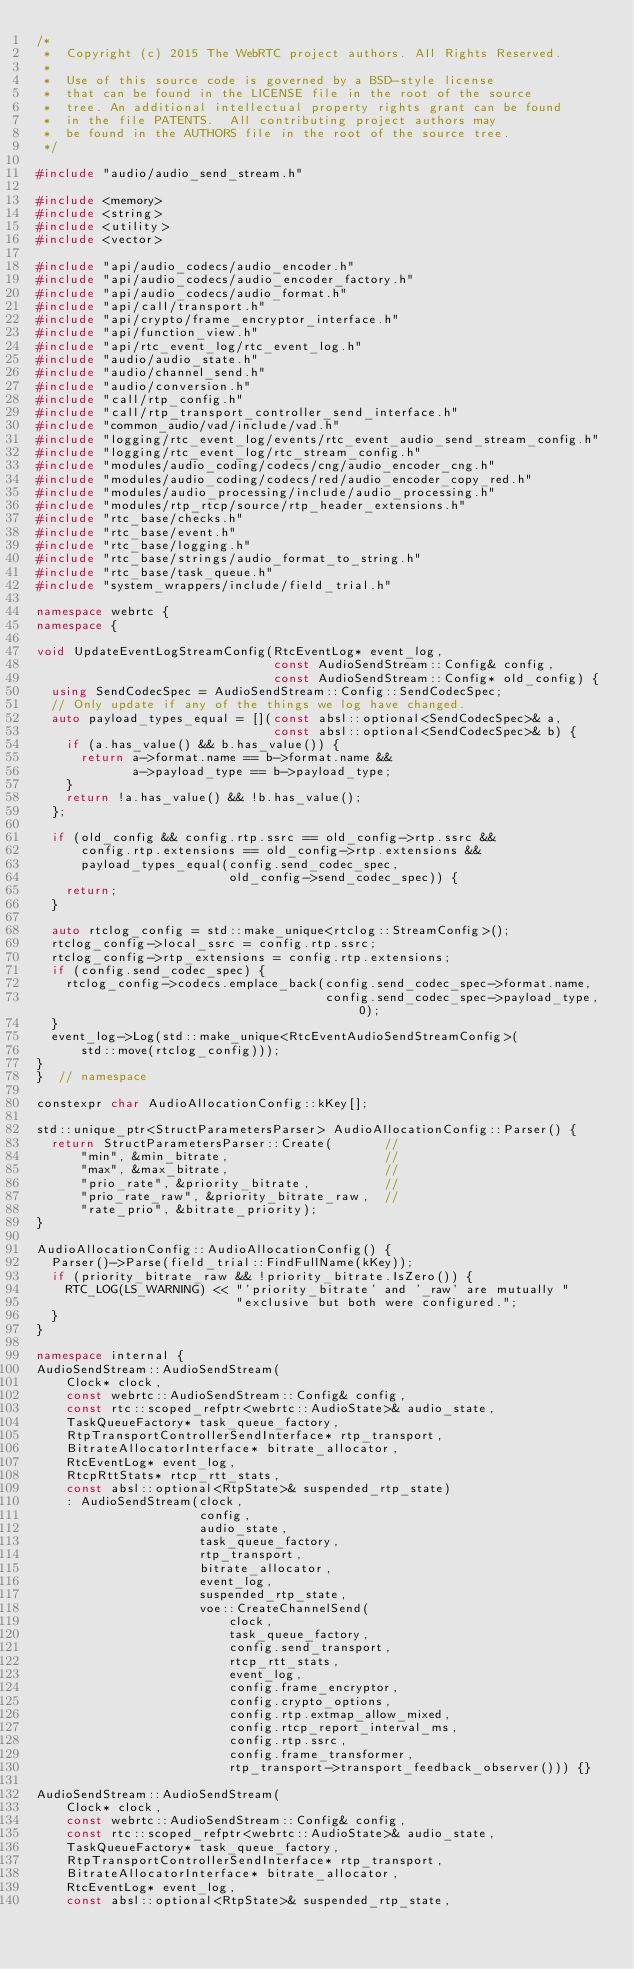Convert code to text. <code><loc_0><loc_0><loc_500><loc_500><_C++_>/*
 *  Copyright (c) 2015 The WebRTC project authors. All Rights Reserved.
 *
 *  Use of this source code is governed by a BSD-style license
 *  that can be found in the LICENSE file in the root of the source
 *  tree. An additional intellectual property rights grant can be found
 *  in the file PATENTS.  All contributing project authors may
 *  be found in the AUTHORS file in the root of the source tree.
 */

#include "audio/audio_send_stream.h"

#include <memory>
#include <string>
#include <utility>
#include <vector>

#include "api/audio_codecs/audio_encoder.h"
#include "api/audio_codecs/audio_encoder_factory.h"
#include "api/audio_codecs/audio_format.h"
#include "api/call/transport.h"
#include "api/crypto/frame_encryptor_interface.h"
#include "api/function_view.h"
#include "api/rtc_event_log/rtc_event_log.h"
#include "audio/audio_state.h"
#include "audio/channel_send.h"
#include "audio/conversion.h"
#include "call/rtp_config.h"
#include "call/rtp_transport_controller_send_interface.h"
#include "common_audio/vad/include/vad.h"
#include "logging/rtc_event_log/events/rtc_event_audio_send_stream_config.h"
#include "logging/rtc_event_log/rtc_stream_config.h"
#include "modules/audio_coding/codecs/cng/audio_encoder_cng.h"
#include "modules/audio_coding/codecs/red/audio_encoder_copy_red.h"
#include "modules/audio_processing/include/audio_processing.h"
#include "modules/rtp_rtcp/source/rtp_header_extensions.h"
#include "rtc_base/checks.h"
#include "rtc_base/event.h"
#include "rtc_base/logging.h"
#include "rtc_base/strings/audio_format_to_string.h"
#include "rtc_base/task_queue.h"
#include "system_wrappers/include/field_trial.h"

namespace webrtc {
namespace {

void UpdateEventLogStreamConfig(RtcEventLog* event_log,
                                const AudioSendStream::Config& config,
                                const AudioSendStream::Config* old_config) {
  using SendCodecSpec = AudioSendStream::Config::SendCodecSpec;
  // Only update if any of the things we log have changed.
  auto payload_types_equal = [](const absl::optional<SendCodecSpec>& a,
                                const absl::optional<SendCodecSpec>& b) {
    if (a.has_value() && b.has_value()) {
      return a->format.name == b->format.name &&
             a->payload_type == b->payload_type;
    }
    return !a.has_value() && !b.has_value();
  };

  if (old_config && config.rtp.ssrc == old_config->rtp.ssrc &&
      config.rtp.extensions == old_config->rtp.extensions &&
      payload_types_equal(config.send_codec_spec,
                          old_config->send_codec_spec)) {
    return;
  }

  auto rtclog_config = std::make_unique<rtclog::StreamConfig>();
  rtclog_config->local_ssrc = config.rtp.ssrc;
  rtclog_config->rtp_extensions = config.rtp.extensions;
  if (config.send_codec_spec) {
    rtclog_config->codecs.emplace_back(config.send_codec_spec->format.name,
                                       config.send_codec_spec->payload_type, 0);
  }
  event_log->Log(std::make_unique<RtcEventAudioSendStreamConfig>(
      std::move(rtclog_config)));
}
}  // namespace

constexpr char AudioAllocationConfig::kKey[];

std::unique_ptr<StructParametersParser> AudioAllocationConfig::Parser() {
  return StructParametersParser::Create(       //
      "min", &min_bitrate,                     //
      "max", &max_bitrate,                     //
      "prio_rate", &priority_bitrate,          //
      "prio_rate_raw", &priority_bitrate_raw,  //
      "rate_prio", &bitrate_priority);
}

AudioAllocationConfig::AudioAllocationConfig() {
  Parser()->Parse(field_trial::FindFullName(kKey));
  if (priority_bitrate_raw && !priority_bitrate.IsZero()) {
    RTC_LOG(LS_WARNING) << "'priority_bitrate' and '_raw' are mutually "
                           "exclusive but both were configured.";
  }
}

namespace internal {
AudioSendStream::AudioSendStream(
    Clock* clock,
    const webrtc::AudioSendStream::Config& config,
    const rtc::scoped_refptr<webrtc::AudioState>& audio_state,
    TaskQueueFactory* task_queue_factory,
    RtpTransportControllerSendInterface* rtp_transport,
    BitrateAllocatorInterface* bitrate_allocator,
    RtcEventLog* event_log,
    RtcpRttStats* rtcp_rtt_stats,
    const absl::optional<RtpState>& suspended_rtp_state)
    : AudioSendStream(clock,
                      config,
                      audio_state,
                      task_queue_factory,
                      rtp_transport,
                      bitrate_allocator,
                      event_log,
                      suspended_rtp_state,
                      voe::CreateChannelSend(
                          clock,
                          task_queue_factory,
                          config.send_transport,
                          rtcp_rtt_stats,
                          event_log,
                          config.frame_encryptor,
                          config.crypto_options,
                          config.rtp.extmap_allow_mixed,
                          config.rtcp_report_interval_ms,
                          config.rtp.ssrc,
                          config.frame_transformer,
                          rtp_transport->transport_feedback_observer())) {}

AudioSendStream::AudioSendStream(
    Clock* clock,
    const webrtc::AudioSendStream::Config& config,
    const rtc::scoped_refptr<webrtc::AudioState>& audio_state,
    TaskQueueFactory* task_queue_factory,
    RtpTransportControllerSendInterface* rtp_transport,
    BitrateAllocatorInterface* bitrate_allocator,
    RtcEventLog* event_log,
    const absl::optional<RtpState>& suspended_rtp_state,</code> 